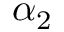<formula> <loc_0><loc_0><loc_500><loc_500>\alpha _ { 2 }</formula> 